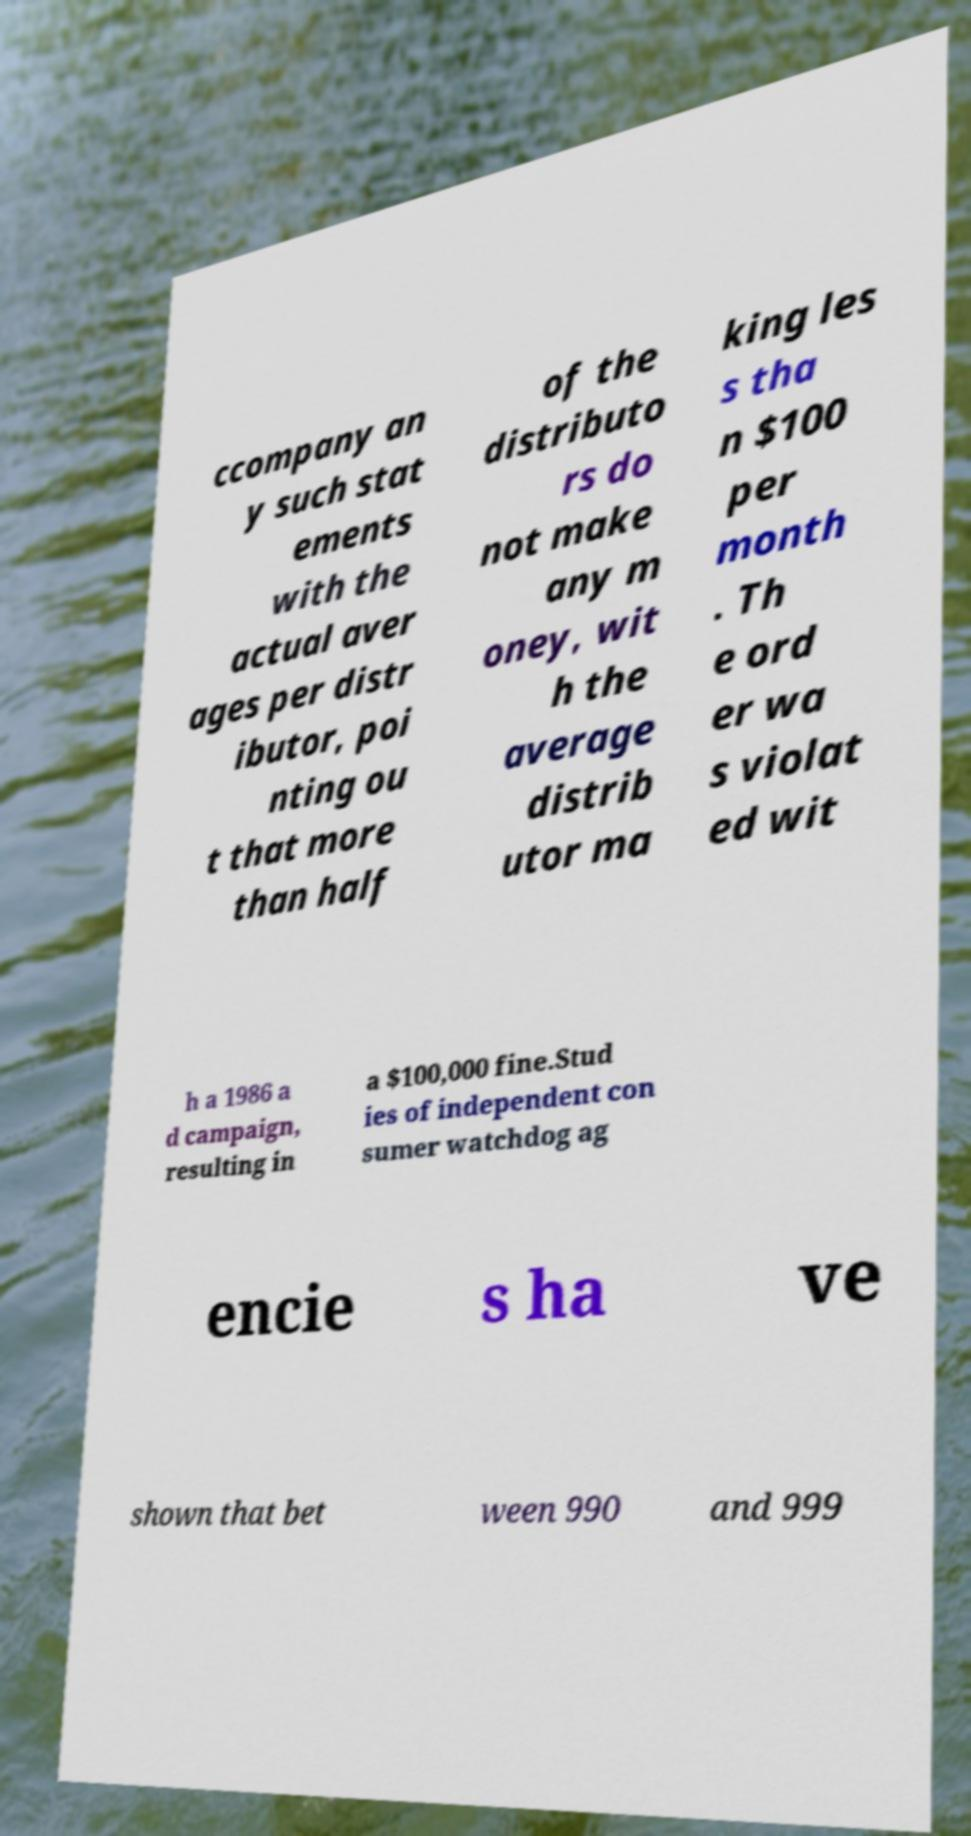I need the written content from this picture converted into text. Can you do that? ccompany an y such stat ements with the actual aver ages per distr ibutor, poi nting ou t that more than half of the distributo rs do not make any m oney, wit h the average distrib utor ma king les s tha n $100 per month . Th e ord er wa s violat ed wit h a 1986 a d campaign, resulting in a $100,000 fine.Stud ies of independent con sumer watchdog ag encie s ha ve shown that bet ween 990 and 999 